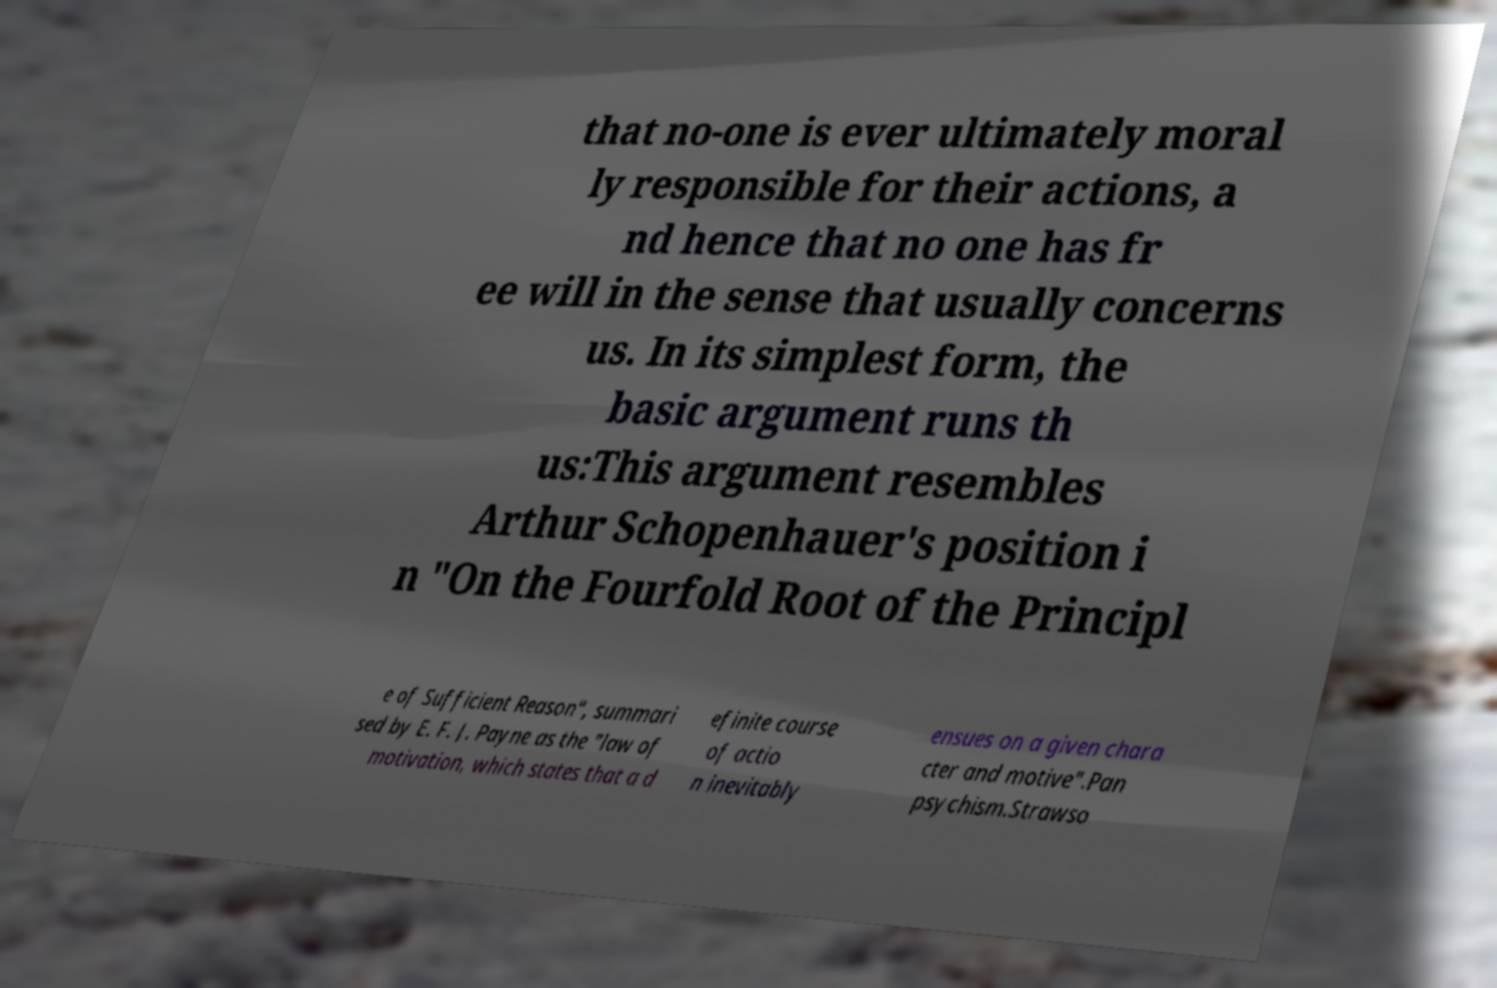There's text embedded in this image that I need extracted. Can you transcribe it verbatim? that no-one is ever ultimately moral ly responsible for their actions, a nd hence that no one has fr ee will in the sense that usually concerns us. In its simplest form, the basic argument runs th us:This argument resembles Arthur Schopenhauer's position i n "On the Fourfold Root of the Principl e of Sufficient Reason", summari sed by E. F. J. Payne as the "law of motivation, which states that a d efinite course of actio n inevitably ensues on a given chara cter and motive".Pan psychism.Strawso 